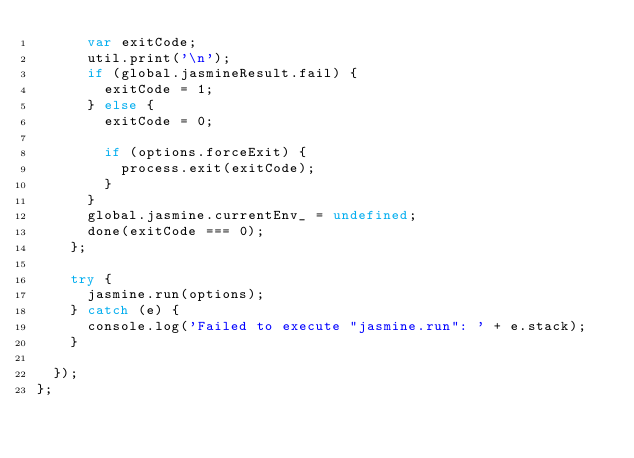<code> <loc_0><loc_0><loc_500><loc_500><_JavaScript_>      var exitCode;
      util.print('\n');
      if (global.jasmineResult.fail) {
        exitCode = 1;
      } else {
        exitCode = 0;

        if (options.forceExit) {
          process.exit(exitCode);
        }
      }
      global.jasmine.currentEnv_ = undefined;
      done(exitCode === 0);
    };

    try {
      jasmine.run(options);
    } catch (e) {
      console.log('Failed to execute "jasmine.run": ' + e.stack);
    }

  });
};</code> 